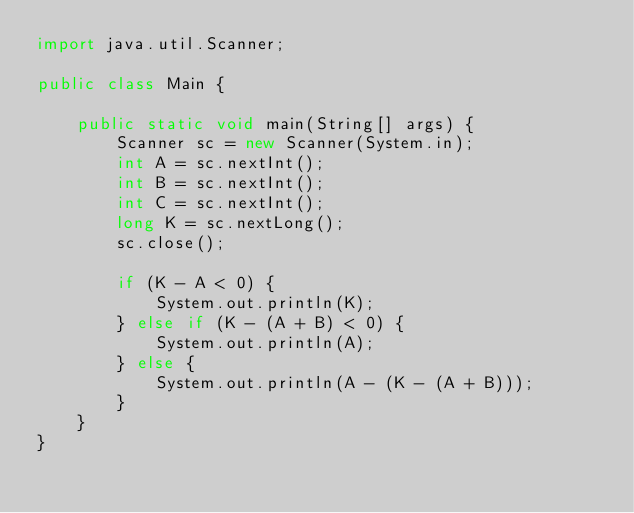<code> <loc_0><loc_0><loc_500><loc_500><_Java_>import java.util.Scanner;

public class Main {

    public static void main(String[] args) {
        Scanner sc = new Scanner(System.in);
        int A = sc.nextInt();
        int B = sc.nextInt();
        int C = sc.nextInt();
        long K = sc.nextLong();
        sc.close();

        if (K - A < 0) {
            System.out.println(K);
        } else if (K - (A + B) < 0) {
            System.out.println(A);
        } else {
            System.out.println(A - (K - (A + B)));
        }
    }
}
</code> 